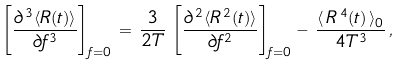<formula> <loc_0><loc_0><loc_500><loc_500>\left [ \frac { \partial ^ { \, 3 } \langle R ( t ) \rangle } { \partial f ^ { 3 } } \right ] _ { f = 0 } \, = \, \frac { 3 } { 2 T } \, \left [ \frac { \partial ^ { \, 2 } \langle R ^ { \, 2 } ( t ) \rangle } { \partial f ^ { 2 } } \right ] _ { f = 0 } - \, \frac { \langle \, R ^ { \, 4 } ( t ) \, \rangle _ { 0 } } { 4 T ^ { 3 } } \, ,</formula> 